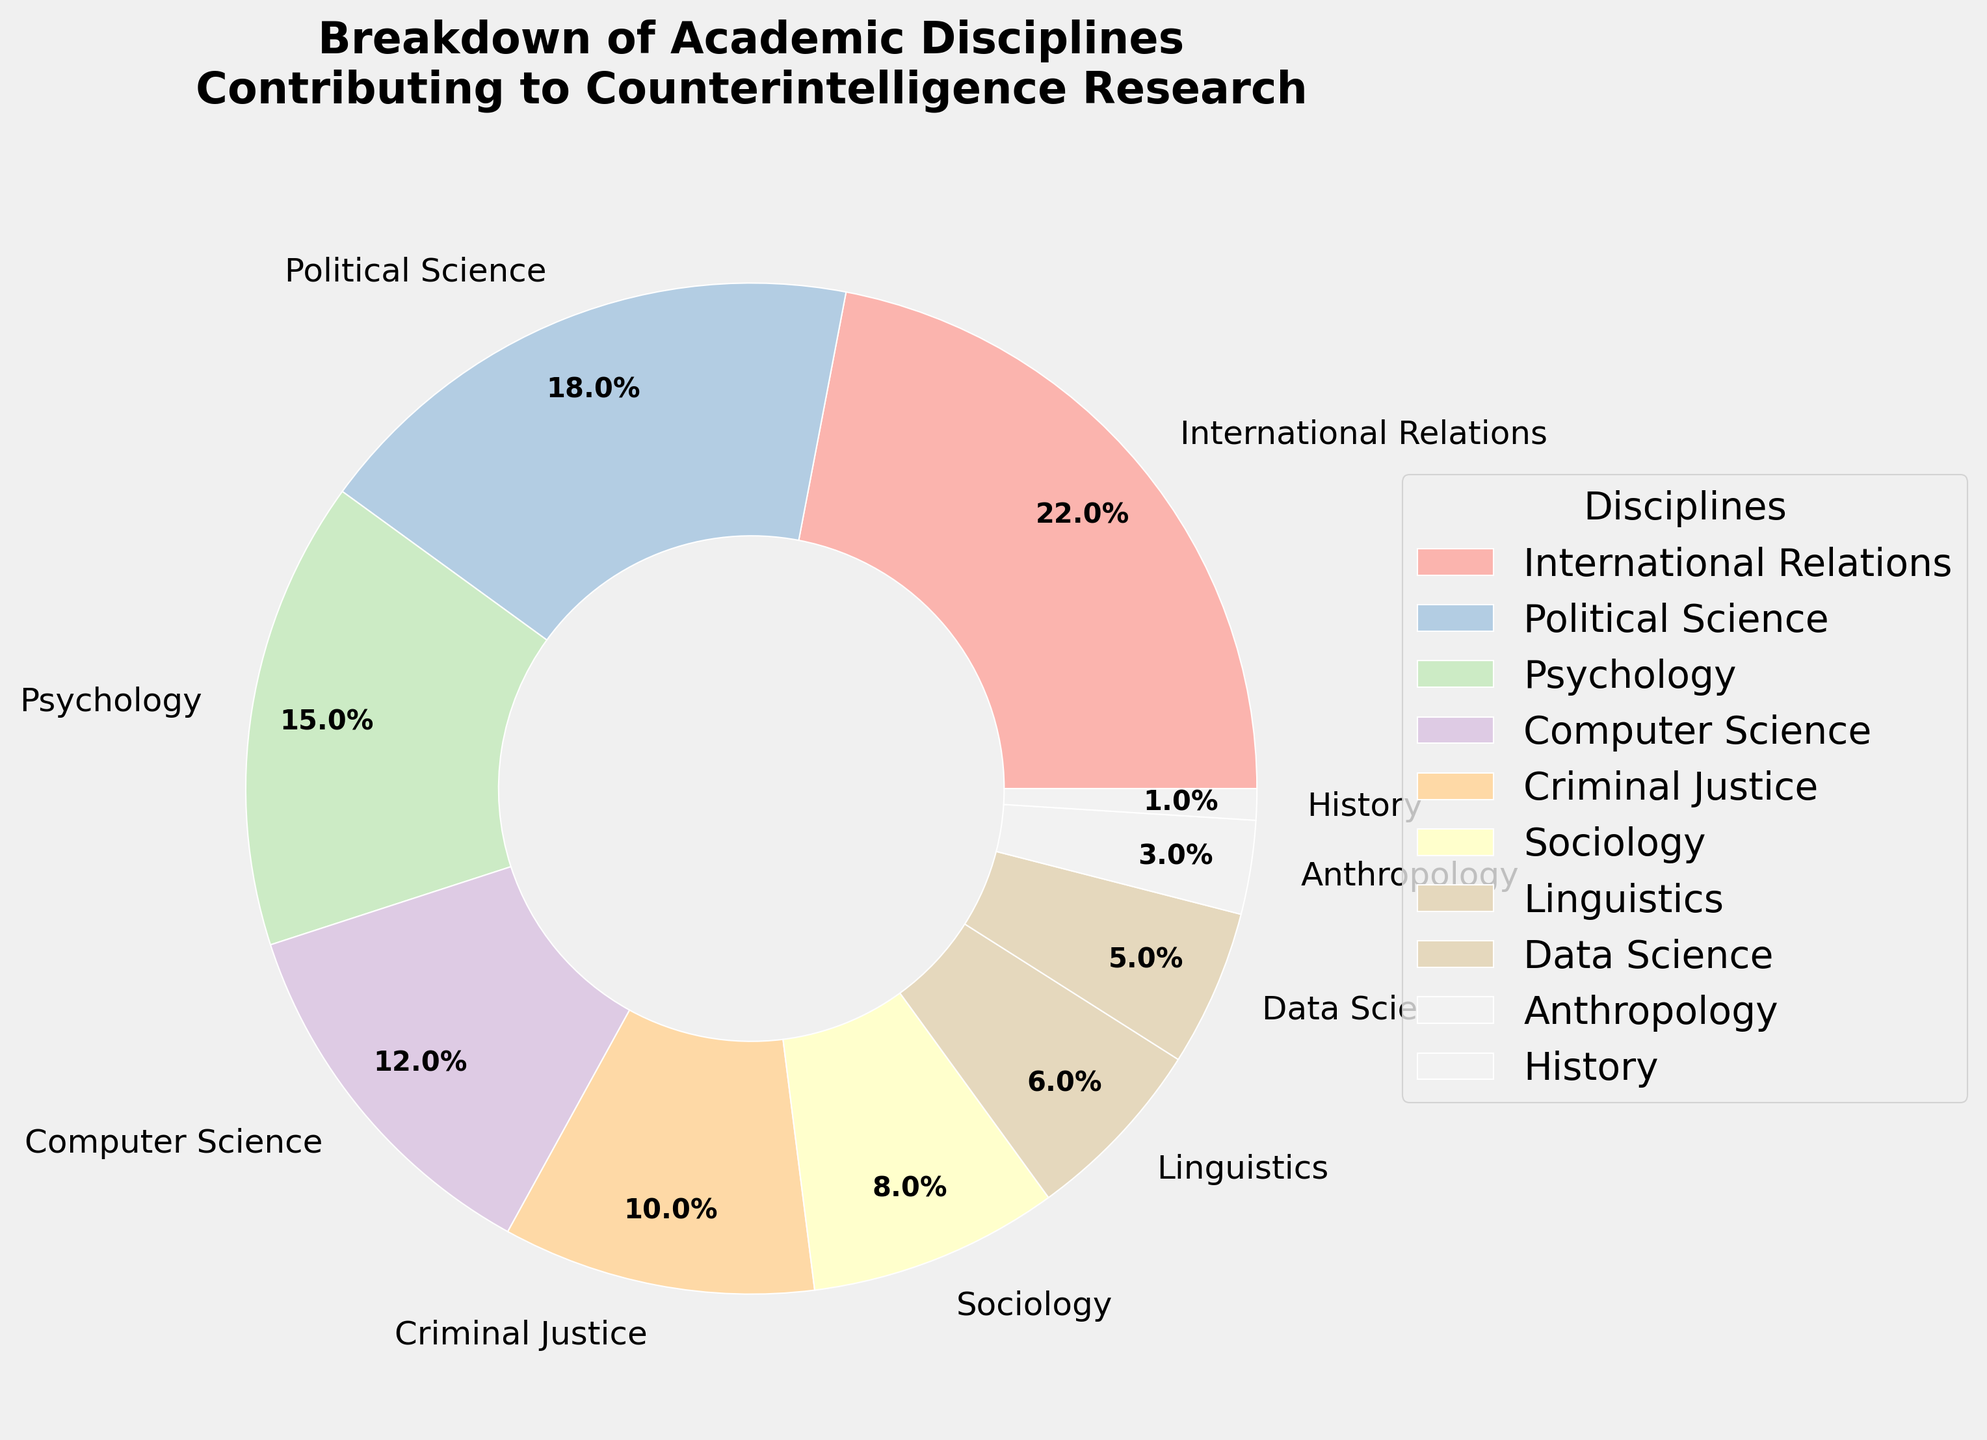Which academic discipline contributes the most to counterintelligence research? The largest slice of the pie chart represents the academic discipline that contributes the most. By observation, International Relations has the largest percentage.
Answer: International Relations What is the combined percentage contribution of Psychology and Computer Science? By observing the chart, Psychology contributes 15% and Computer Science contributes 12%. Adding these two percentages gives 15% + 12% = 27%.
Answer: 27% Which two disciplines have the smallest contributions, and what is their total percentage? The smallest slices of the pie chart are for History and Anthropology. History contributes 1% and Anthropology contributes 3%. Their combined contribution is 1% + 3% = 4%.
Answer: History and Anthropology, 4% Is the contribution of Sociology greater than that of Data Science? Observing the pie chart, Sociology contributes 8%, while Data Science contributes 5%. Hence, Sociology's contribution is greater.
Answer: Yes Calculate the average percentage contribution of International Relations, Political Science, and Psychology. The contributions of International Relations, Political Science, and Psychology are 22%, 18%, and 15%, respectively. The average is calculated as (22 + 18 + 15) / 3 = 55 / 3 ≈ 18.33%.
Answer: 18.33% How much more does Sociology contribute than Anthropology? Sociology's contribution is 8%, and Anthropology's is 3%. The difference between them is 8% - 3% = 5%.
Answer: 5% Which disciplines contribute exactly half of Psychology's contribution, and what are they? Psychology contributes 15%. Half of that is 15% / 2 = 7.5%. By observing the pie chart, no disciplines contribute exactly 7.5%, but two disciplines are close: Sociology at 8% and Linguistics at 6%.
Answer: None Compare and determine if the combined contribution of Criminal Justice and Data Science is greater than that of Political Science. Criminal Justice contributes 10% and Data Science contributes 5%. Their combined contribution is 10% + 5% = 15%. Political Science contributes 18%. Therefore, the combined contribution of Criminal Justice and Data Science is less.
Answer: No What is the contribution difference between the highest contributing discipline and the lowest contributing discipline? The highest contributing discipline is International Relations at 22%, and the lowest is History at 1%. The difference is 22% - 1% = 21%.
Answer: 21% What percentage of the disciplines contribute less than 10% each? By observing the chart, the disciplines contributing less than 10% are Sociology (8%), Linguistics (6%), Data Science (5%), Anthropology (3%), and History (1%). The total number of these disciplines is 5 out of 10. Thus, 50% of the disciplines contribute less than 10% each.
Answer: 50% 